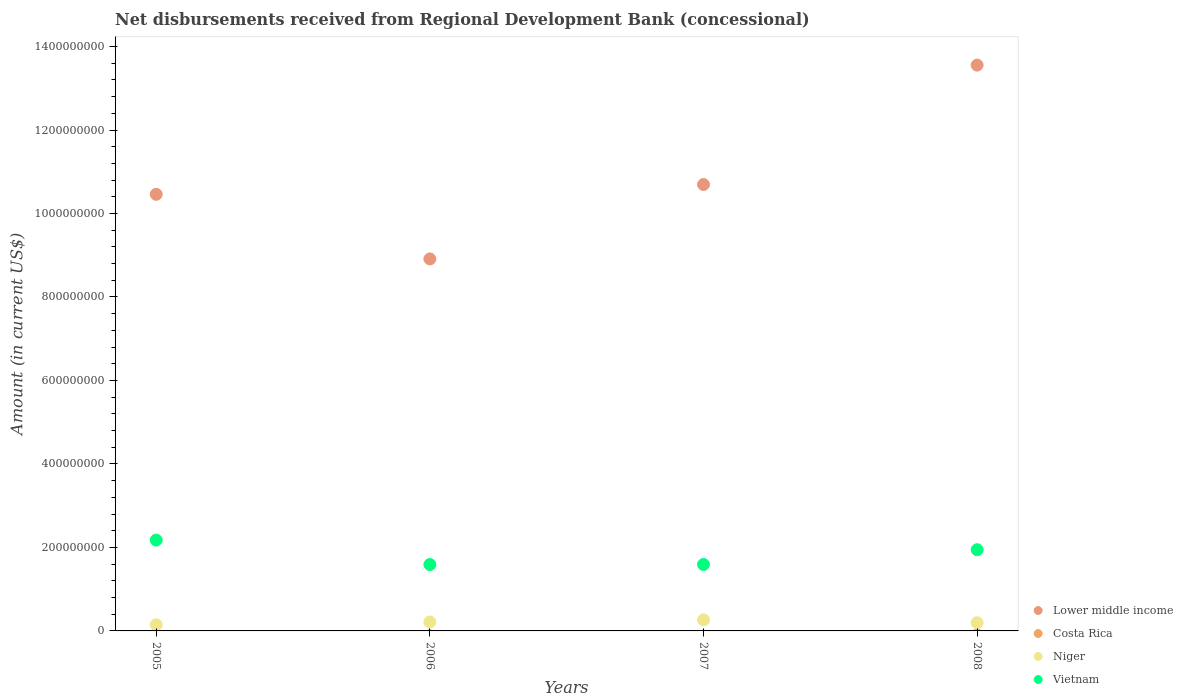How many different coloured dotlines are there?
Offer a terse response. 3. Is the number of dotlines equal to the number of legend labels?
Keep it short and to the point. No. Across all years, what is the maximum amount of disbursements received from Regional Development Bank in Niger?
Keep it short and to the point. 2.66e+07. In which year was the amount of disbursements received from Regional Development Bank in Niger maximum?
Your answer should be compact. 2007. What is the total amount of disbursements received from Regional Development Bank in Vietnam in the graph?
Offer a very short reply. 7.30e+08. What is the difference between the amount of disbursements received from Regional Development Bank in Niger in 2007 and that in 2008?
Offer a terse response. 6.90e+06. What is the difference between the amount of disbursements received from Regional Development Bank in Costa Rica in 2005 and the amount of disbursements received from Regional Development Bank in Vietnam in 2008?
Your answer should be very brief. -1.95e+08. What is the average amount of disbursements received from Regional Development Bank in Costa Rica per year?
Give a very brief answer. 0. In the year 2008, what is the difference between the amount of disbursements received from Regional Development Bank in Vietnam and amount of disbursements received from Regional Development Bank in Niger?
Give a very brief answer. 1.75e+08. What is the ratio of the amount of disbursements received from Regional Development Bank in Lower middle income in 2006 to that in 2008?
Offer a terse response. 0.66. Is the difference between the amount of disbursements received from Regional Development Bank in Vietnam in 2005 and 2008 greater than the difference between the amount of disbursements received from Regional Development Bank in Niger in 2005 and 2008?
Offer a very short reply. Yes. What is the difference between the highest and the second highest amount of disbursements received from Regional Development Bank in Lower middle income?
Offer a very short reply. 2.86e+08. What is the difference between the highest and the lowest amount of disbursements received from Regional Development Bank in Lower middle income?
Offer a very short reply. 4.64e+08. In how many years, is the amount of disbursements received from Regional Development Bank in Vietnam greater than the average amount of disbursements received from Regional Development Bank in Vietnam taken over all years?
Keep it short and to the point. 2. Is the sum of the amount of disbursements received from Regional Development Bank in Niger in 2007 and 2008 greater than the maximum amount of disbursements received from Regional Development Bank in Costa Rica across all years?
Give a very brief answer. Yes. Does the amount of disbursements received from Regional Development Bank in Costa Rica monotonically increase over the years?
Offer a terse response. No. Is the amount of disbursements received from Regional Development Bank in Niger strictly greater than the amount of disbursements received from Regional Development Bank in Vietnam over the years?
Keep it short and to the point. No. Is the amount of disbursements received from Regional Development Bank in Costa Rica strictly less than the amount of disbursements received from Regional Development Bank in Lower middle income over the years?
Offer a very short reply. Yes. How many years are there in the graph?
Provide a short and direct response. 4. Does the graph contain grids?
Your answer should be very brief. No. Where does the legend appear in the graph?
Your answer should be compact. Bottom right. What is the title of the graph?
Your answer should be compact. Net disbursements received from Regional Development Bank (concessional). Does "Uganda" appear as one of the legend labels in the graph?
Make the answer very short. No. What is the label or title of the X-axis?
Your answer should be compact. Years. What is the Amount (in current US$) in Lower middle income in 2005?
Your answer should be very brief. 1.05e+09. What is the Amount (in current US$) of Costa Rica in 2005?
Give a very brief answer. 0. What is the Amount (in current US$) of Niger in 2005?
Ensure brevity in your answer.  1.47e+07. What is the Amount (in current US$) in Vietnam in 2005?
Make the answer very short. 2.18e+08. What is the Amount (in current US$) in Lower middle income in 2006?
Ensure brevity in your answer.  8.91e+08. What is the Amount (in current US$) in Niger in 2006?
Offer a very short reply. 2.15e+07. What is the Amount (in current US$) of Vietnam in 2006?
Provide a short and direct response. 1.59e+08. What is the Amount (in current US$) of Lower middle income in 2007?
Provide a short and direct response. 1.07e+09. What is the Amount (in current US$) of Costa Rica in 2007?
Offer a very short reply. 0. What is the Amount (in current US$) in Niger in 2007?
Offer a very short reply. 2.66e+07. What is the Amount (in current US$) in Vietnam in 2007?
Keep it short and to the point. 1.59e+08. What is the Amount (in current US$) of Lower middle income in 2008?
Give a very brief answer. 1.36e+09. What is the Amount (in current US$) in Niger in 2008?
Keep it short and to the point. 1.97e+07. What is the Amount (in current US$) in Vietnam in 2008?
Your response must be concise. 1.95e+08. Across all years, what is the maximum Amount (in current US$) of Lower middle income?
Your response must be concise. 1.36e+09. Across all years, what is the maximum Amount (in current US$) in Niger?
Provide a short and direct response. 2.66e+07. Across all years, what is the maximum Amount (in current US$) of Vietnam?
Make the answer very short. 2.18e+08. Across all years, what is the minimum Amount (in current US$) of Lower middle income?
Provide a succinct answer. 8.91e+08. Across all years, what is the minimum Amount (in current US$) in Niger?
Provide a short and direct response. 1.47e+07. Across all years, what is the minimum Amount (in current US$) in Vietnam?
Offer a very short reply. 1.59e+08. What is the total Amount (in current US$) in Lower middle income in the graph?
Your answer should be compact. 4.36e+09. What is the total Amount (in current US$) of Costa Rica in the graph?
Your answer should be very brief. 0. What is the total Amount (in current US$) of Niger in the graph?
Keep it short and to the point. 8.25e+07. What is the total Amount (in current US$) of Vietnam in the graph?
Keep it short and to the point. 7.30e+08. What is the difference between the Amount (in current US$) in Lower middle income in 2005 and that in 2006?
Give a very brief answer. 1.55e+08. What is the difference between the Amount (in current US$) in Niger in 2005 and that in 2006?
Your answer should be very brief. -6.79e+06. What is the difference between the Amount (in current US$) of Vietnam in 2005 and that in 2006?
Offer a terse response. 5.86e+07. What is the difference between the Amount (in current US$) of Lower middle income in 2005 and that in 2007?
Give a very brief answer. -2.34e+07. What is the difference between the Amount (in current US$) in Niger in 2005 and that in 2007?
Provide a short and direct response. -1.18e+07. What is the difference between the Amount (in current US$) in Vietnam in 2005 and that in 2007?
Your answer should be compact. 5.84e+07. What is the difference between the Amount (in current US$) in Lower middle income in 2005 and that in 2008?
Provide a short and direct response. -3.09e+08. What is the difference between the Amount (in current US$) in Niger in 2005 and that in 2008?
Give a very brief answer. -4.94e+06. What is the difference between the Amount (in current US$) in Vietnam in 2005 and that in 2008?
Provide a short and direct response. 2.31e+07. What is the difference between the Amount (in current US$) of Lower middle income in 2006 and that in 2007?
Your answer should be compact. -1.78e+08. What is the difference between the Amount (in current US$) of Niger in 2006 and that in 2007?
Ensure brevity in your answer.  -5.05e+06. What is the difference between the Amount (in current US$) of Vietnam in 2006 and that in 2007?
Make the answer very short. -2.31e+05. What is the difference between the Amount (in current US$) of Lower middle income in 2006 and that in 2008?
Offer a terse response. -4.64e+08. What is the difference between the Amount (in current US$) in Niger in 2006 and that in 2008?
Make the answer very short. 1.85e+06. What is the difference between the Amount (in current US$) in Vietnam in 2006 and that in 2008?
Make the answer very short. -3.55e+07. What is the difference between the Amount (in current US$) in Lower middle income in 2007 and that in 2008?
Offer a terse response. -2.86e+08. What is the difference between the Amount (in current US$) in Niger in 2007 and that in 2008?
Offer a very short reply. 6.90e+06. What is the difference between the Amount (in current US$) of Vietnam in 2007 and that in 2008?
Keep it short and to the point. -3.53e+07. What is the difference between the Amount (in current US$) in Lower middle income in 2005 and the Amount (in current US$) in Niger in 2006?
Give a very brief answer. 1.02e+09. What is the difference between the Amount (in current US$) in Lower middle income in 2005 and the Amount (in current US$) in Vietnam in 2006?
Your answer should be very brief. 8.87e+08. What is the difference between the Amount (in current US$) in Niger in 2005 and the Amount (in current US$) in Vietnam in 2006?
Offer a terse response. -1.44e+08. What is the difference between the Amount (in current US$) in Lower middle income in 2005 and the Amount (in current US$) in Niger in 2007?
Give a very brief answer. 1.02e+09. What is the difference between the Amount (in current US$) of Lower middle income in 2005 and the Amount (in current US$) of Vietnam in 2007?
Offer a very short reply. 8.87e+08. What is the difference between the Amount (in current US$) in Niger in 2005 and the Amount (in current US$) in Vietnam in 2007?
Provide a short and direct response. -1.44e+08. What is the difference between the Amount (in current US$) of Lower middle income in 2005 and the Amount (in current US$) of Niger in 2008?
Ensure brevity in your answer.  1.03e+09. What is the difference between the Amount (in current US$) of Lower middle income in 2005 and the Amount (in current US$) of Vietnam in 2008?
Ensure brevity in your answer.  8.51e+08. What is the difference between the Amount (in current US$) of Niger in 2005 and the Amount (in current US$) of Vietnam in 2008?
Offer a terse response. -1.80e+08. What is the difference between the Amount (in current US$) in Lower middle income in 2006 and the Amount (in current US$) in Niger in 2007?
Provide a succinct answer. 8.65e+08. What is the difference between the Amount (in current US$) of Lower middle income in 2006 and the Amount (in current US$) of Vietnam in 2007?
Make the answer very short. 7.32e+08. What is the difference between the Amount (in current US$) in Niger in 2006 and the Amount (in current US$) in Vietnam in 2007?
Offer a terse response. -1.38e+08. What is the difference between the Amount (in current US$) in Lower middle income in 2006 and the Amount (in current US$) in Niger in 2008?
Give a very brief answer. 8.72e+08. What is the difference between the Amount (in current US$) of Lower middle income in 2006 and the Amount (in current US$) of Vietnam in 2008?
Keep it short and to the point. 6.97e+08. What is the difference between the Amount (in current US$) in Niger in 2006 and the Amount (in current US$) in Vietnam in 2008?
Ensure brevity in your answer.  -1.73e+08. What is the difference between the Amount (in current US$) of Lower middle income in 2007 and the Amount (in current US$) of Niger in 2008?
Your answer should be very brief. 1.05e+09. What is the difference between the Amount (in current US$) of Lower middle income in 2007 and the Amount (in current US$) of Vietnam in 2008?
Ensure brevity in your answer.  8.75e+08. What is the difference between the Amount (in current US$) of Niger in 2007 and the Amount (in current US$) of Vietnam in 2008?
Ensure brevity in your answer.  -1.68e+08. What is the average Amount (in current US$) in Lower middle income per year?
Your answer should be very brief. 1.09e+09. What is the average Amount (in current US$) in Costa Rica per year?
Give a very brief answer. 0. What is the average Amount (in current US$) of Niger per year?
Offer a very short reply. 2.06e+07. What is the average Amount (in current US$) in Vietnam per year?
Give a very brief answer. 1.83e+08. In the year 2005, what is the difference between the Amount (in current US$) in Lower middle income and Amount (in current US$) in Niger?
Keep it short and to the point. 1.03e+09. In the year 2005, what is the difference between the Amount (in current US$) of Lower middle income and Amount (in current US$) of Vietnam?
Your response must be concise. 8.28e+08. In the year 2005, what is the difference between the Amount (in current US$) of Niger and Amount (in current US$) of Vietnam?
Provide a short and direct response. -2.03e+08. In the year 2006, what is the difference between the Amount (in current US$) of Lower middle income and Amount (in current US$) of Niger?
Ensure brevity in your answer.  8.70e+08. In the year 2006, what is the difference between the Amount (in current US$) of Lower middle income and Amount (in current US$) of Vietnam?
Your answer should be very brief. 7.32e+08. In the year 2006, what is the difference between the Amount (in current US$) in Niger and Amount (in current US$) in Vietnam?
Provide a succinct answer. -1.37e+08. In the year 2007, what is the difference between the Amount (in current US$) in Lower middle income and Amount (in current US$) in Niger?
Give a very brief answer. 1.04e+09. In the year 2007, what is the difference between the Amount (in current US$) in Lower middle income and Amount (in current US$) in Vietnam?
Your response must be concise. 9.10e+08. In the year 2007, what is the difference between the Amount (in current US$) of Niger and Amount (in current US$) of Vietnam?
Give a very brief answer. -1.33e+08. In the year 2008, what is the difference between the Amount (in current US$) in Lower middle income and Amount (in current US$) in Niger?
Your answer should be very brief. 1.34e+09. In the year 2008, what is the difference between the Amount (in current US$) in Lower middle income and Amount (in current US$) in Vietnam?
Keep it short and to the point. 1.16e+09. In the year 2008, what is the difference between the Amount (in current US$) in Niger and Amount (in current US$) in Vietnam?
Keep it short and to the point. -1.75e+08. What is the ratio of the Amount (in current US$) in Lower middle income in 2005 to that in 2006?
Keep it short and to the point. 1.17. What is the ratio of the Amount (in current US$) in Niger in 2005 to that in 2006?
Provide a short and direct response. 0.68. What is the ratio of the Amount (in current US$) in Vietnam in 2005 to that in 2006?
Your answer should be compact. 1.37. What is the ratio of the Amount (in current US$) of Lower middle income in 2005 to that in 2007?
Offer a terse response. 0.98. What is the ratio of the Amount (in current US$) in Niger in 2005 to that in 2007?
Your response must be concise. 0.55. What is the ratio of the Amount (in current US$) of Vietnam in 2005 to that in 2007?
Keep it short and to the point. 1.37. What is the ratio of the Amount (in current US$) in Lower middle income in 2005 to that in 2008?
Provide a short and direct response. 0.77. What is the ratio of the Amount (in current US$) in Niger in 2005 to that in 2008?
Offer a very short reply. 0.75. What is the ratio of the Amount (in current US$) of Vietnam in 2005 to that in 2008?
Give a very brief answer. 1.12. What is the ratio of the Amount (in current US$) in Lower middle income in 2006 to that in 2007?
Provide a succinct answer. 0.83. What is the ratio of the Amount (in current US$) in Niger in 2006 to that in 2007?
Offer a terse response. 0.81. What is the ratio of the Amount (in current US$) of Lower middle income in 2006 to that in 2008?
Your response must be concise. 0.66. What is the ratio of the Amount (in current US$) of Niger in 2006 to that in 2008?
Make the answer very short. 1.09. What is the ratio of the Amount (in current US$) of Vietnam in 2006 to that in 2008?
Offer a terse response. 0.82. What is the ratio of the Amount (in current US$) of Lower middle income in 2007 to that in 2008?
Provide a succinct answer. 0.79. What is the ratio of the Amount (in current US$) in Niger in 2007 to that in 2008?
Give a very brief answer. 1.35. What is the ratio of the Amount (in current US$) of Vietnam in 2007 to that in 2008?
Give a very brief answer. 0.82. What is the difference between the highest and the second highest Amount (in current US$) of Lower middle income?
Make the answer very short. 2.86e+08. What is the difference between the highest and the second highest Amount (in current US$) in Niger?
Provide a short and direct response. 5.05e+06. What is the difference between the highest and the second highest Amount (in current US$) in Vietnam?
Give a very brief answer. 2.31e+07. What is the difference between the highest and the lowest Amount (in current US$) in Lower middle income?
Ensure brevity in your answer.  4.64e+08. What is the difference between the highest and the lowest Amount (in current US$) of Niger?
Your response must be concise. 1.18e+07. What is the difference between the highest and the lowest Amount (in current US$) of Vietnam?
Make the answer very short. 5.86e+07. 